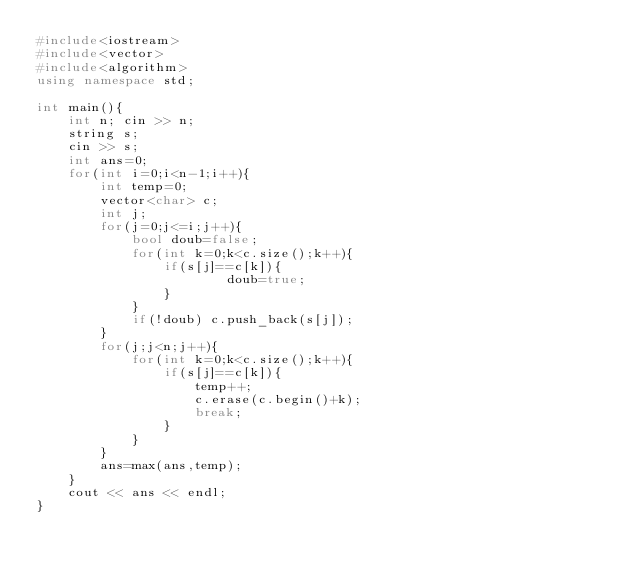Convert code to text. <code><loc_0><loc_0><loc_500><loc_500><_C++_>#include<iostream>
#include<vector>
#include<algorithm>
using namespace std;

int main(){
	int n; cin >> n;
	string s;
	cin >> s;
	int ans=0;
	for(int i=0;i<n-1;i++){
		int temp=0;
		vector<char> c;
		int j;
		for(j=0;j<=i;j++){
			bool doub=false;
			for(int k=0;k<c.size();k++){
				if(s[j]==c[k]){
						doub=true;
				}
			}
			if(!doub) c.push_back(s[j]);
		}
		for(j;j<n;j++){
			for(int k=0;k<c.size();k++){
				if(s[j]==c[k]){
					temp++;
					c.erase(c.begin()+k);
					break;
				}
			}
		}
		ans=max(ans,temp);
	}
	cout << ans << endl;
}
</code> 